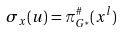<formula> <loc_0><loc_0><loc_500><loc_500>\sigma _ { x } ( u ) = \pi _ { G ^ { * } } ^ { \# } ( x ^ { l } )</formula> 